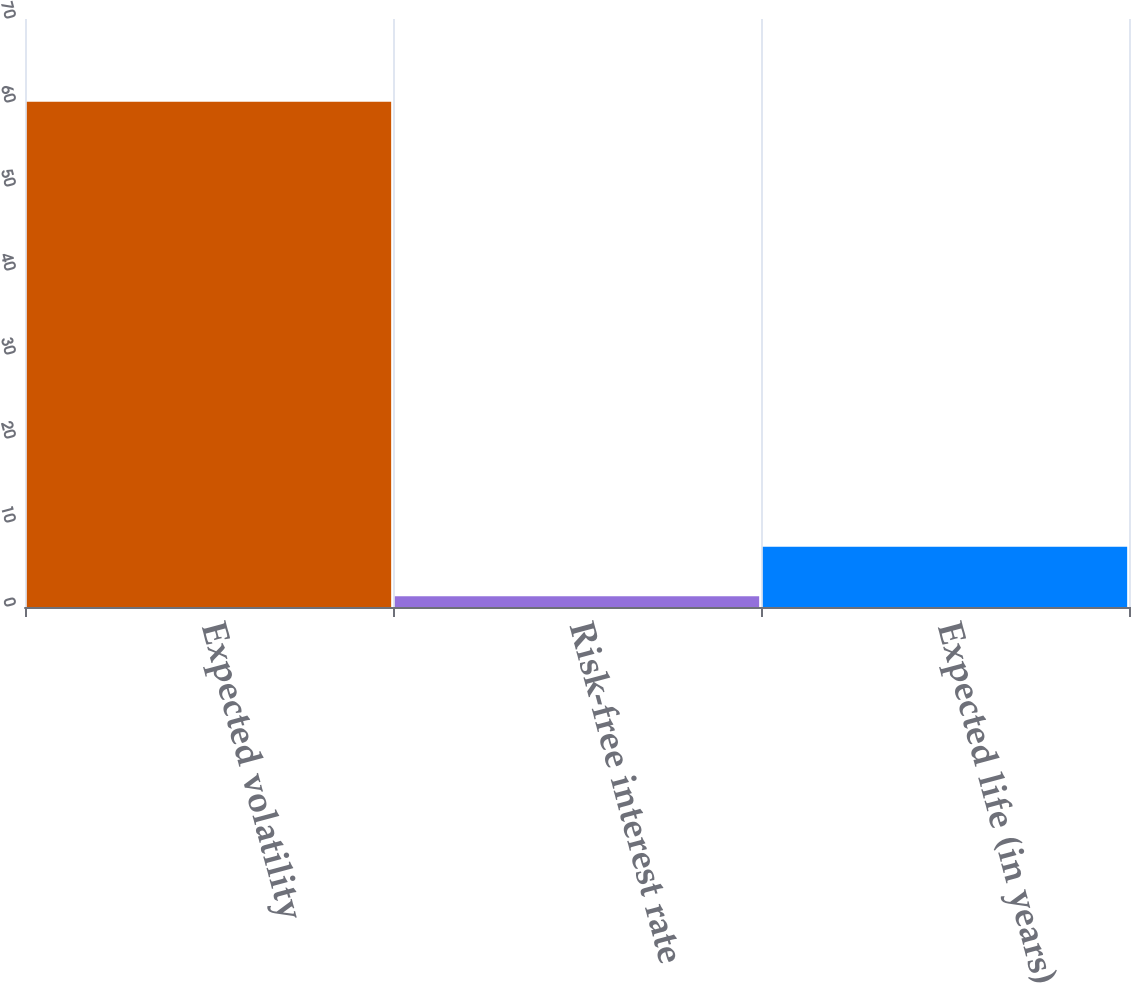Convert chart. <chart><loc_0><loc_0><loc_500><loc_500><bar_chart><fcel>Expected volatility<fcel>Risk-free interest rate<fcel>Expected life (in years)<nl><fcel>60.14<fcel>1.29<fcel>7.18<nl></chart> 